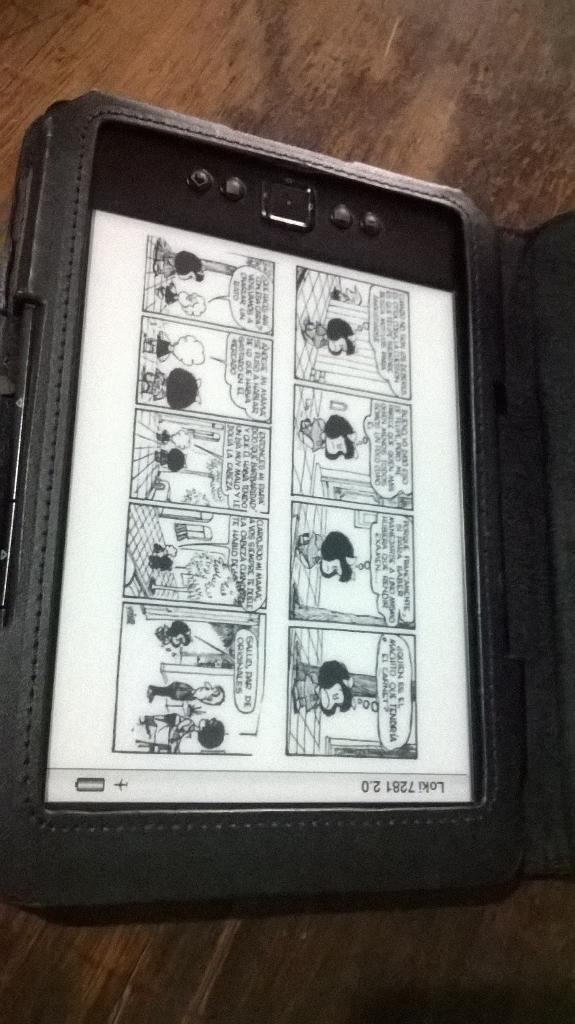What type of furniture is present in the image? There is a table in the image. What is on the table in the image? There is a tab on the table. What can be found on the tab? The tab contains cartoon pictures. Is there a chain attached to the table in the image? No, there is no chain attached to the table in the image. 